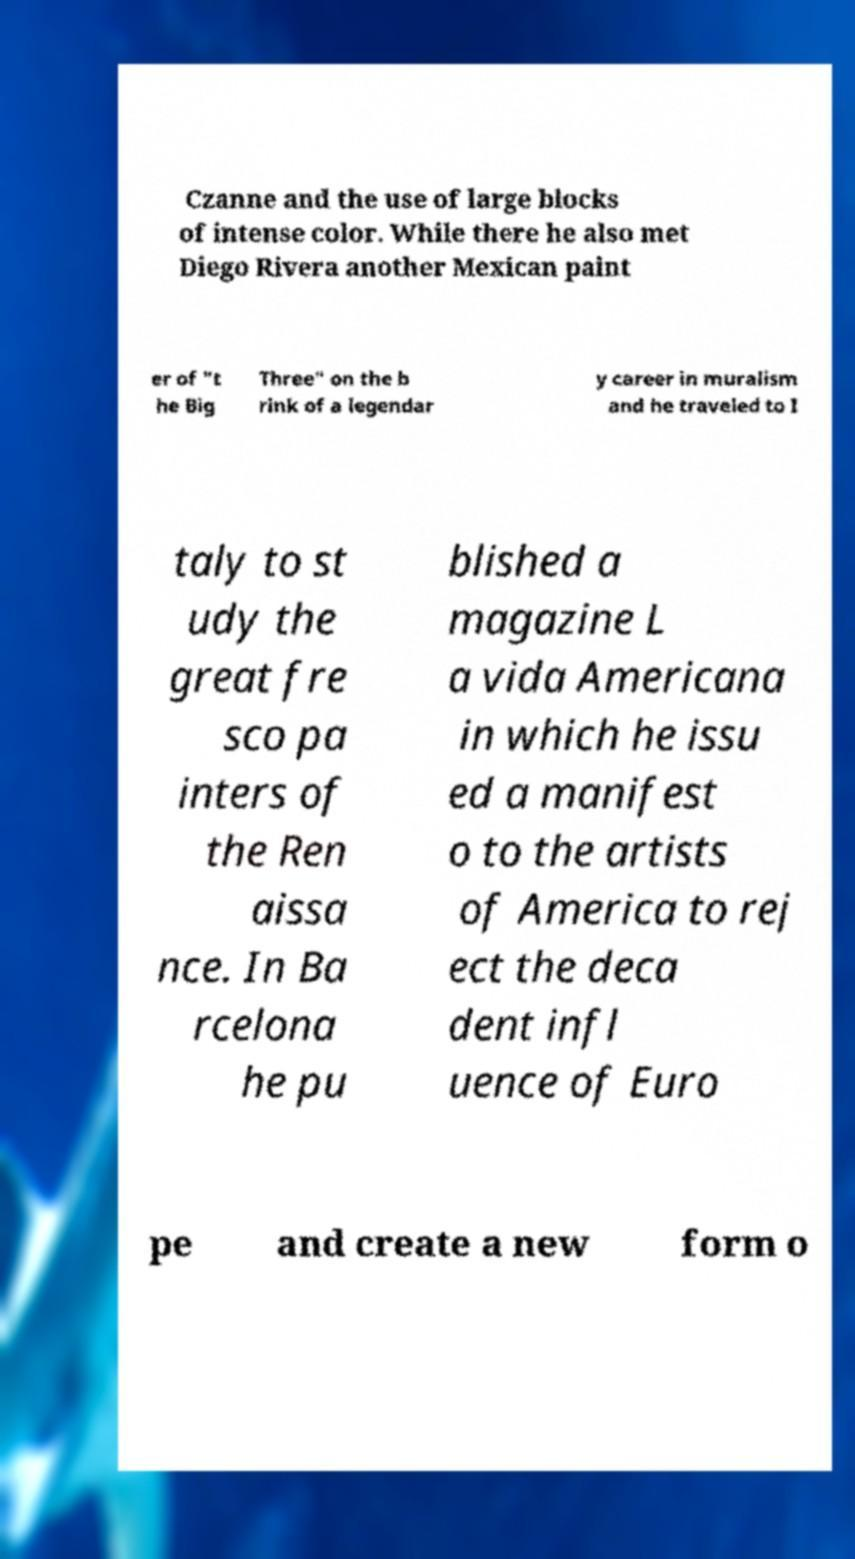Could you assist in decoding the text presented in this image and type it out clearly? Czanne and the use of large blocks of intense color. While there he also met Diego Rivera another Mexican paint er of "t he Big Three" on the b rink of a legendar y career in muralism and he traveled to I taly to st udy the great fre sco pa inters of the Ren aissa nce. In Ba rcelona he pu blished a magazine L a vida Americana in which he issu ed a manifest o to the artists of America to rej ect the deca dent infl uence of Euro pe and create a new form o 